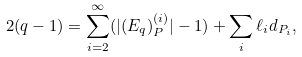Convert formula to latex. <formula><loc_0><loc_0><loc_500><loc_500>2 ( q - 1 ) = \sum _ { i = 2 } ^ { \infty } ( | ( E _ { q } ) _ { P } ^ { ( i ) } | - 1 ) + \sum _ { i } \ell _ { i } d _ { P _ { i } } ,</formula> 